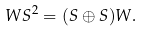Convert formula to latex. <formula><loc_0><loc_0><loc_500><loc_500>W S ^ { 2 } = ( S \oplus S ) W .</formula> 